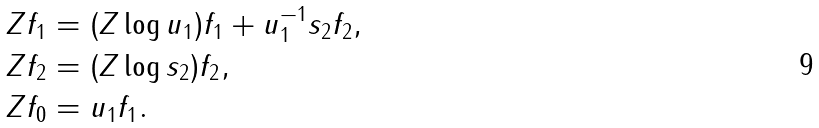<formula> <loc_0><loc_0><loc_500><loc_500>Z f _ { 1 } & = ( Z \log u _ { 1 } ) f _ { 1 } + u _ { 1 } ^ { - 1 } s _ { 2 } f _ { 2 } , \\ Z f _ { 2 } & = ( Z \log s _ { 2 } ) f _ { 2 } , \\ Z f _ { 0 } & = u _ { 1 } f _ { 1 } .</formula> 